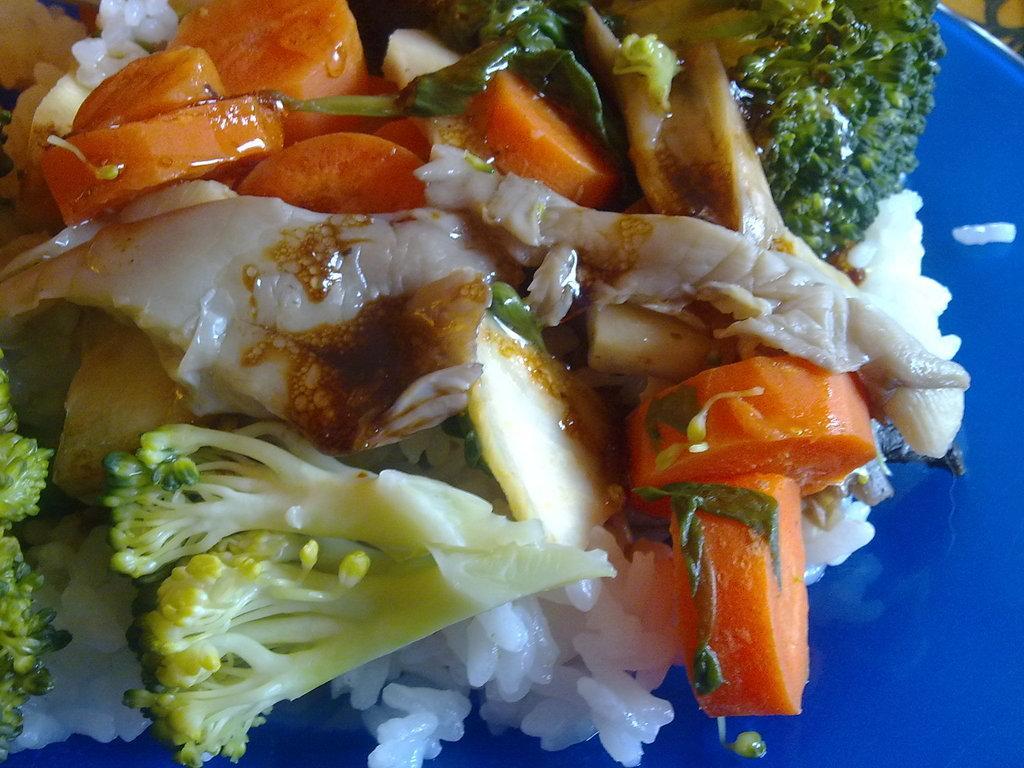How would you summarize this image in a sentence or two? In this image, we can see a plate contains some food. 